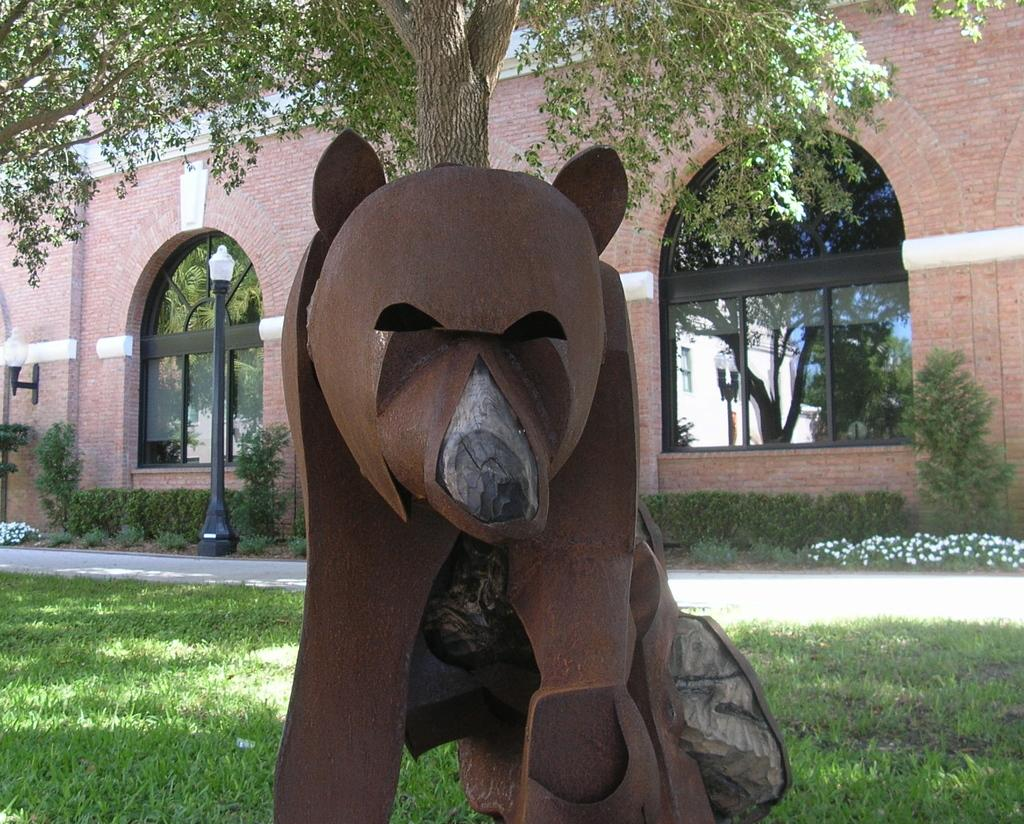What is the main object in the foreground of the image? There is a tree in the image, with a metal sheet in the shape of a bear attached to it. What can be seen in the background of the image? There is a road, plants, and a building visible in the background of the image. What type of wrist accessory is hanging from the tree in the image? There is no wrist accessory present in the image; it features a tree with a metal sheet in the shape of a bear attached to it. 